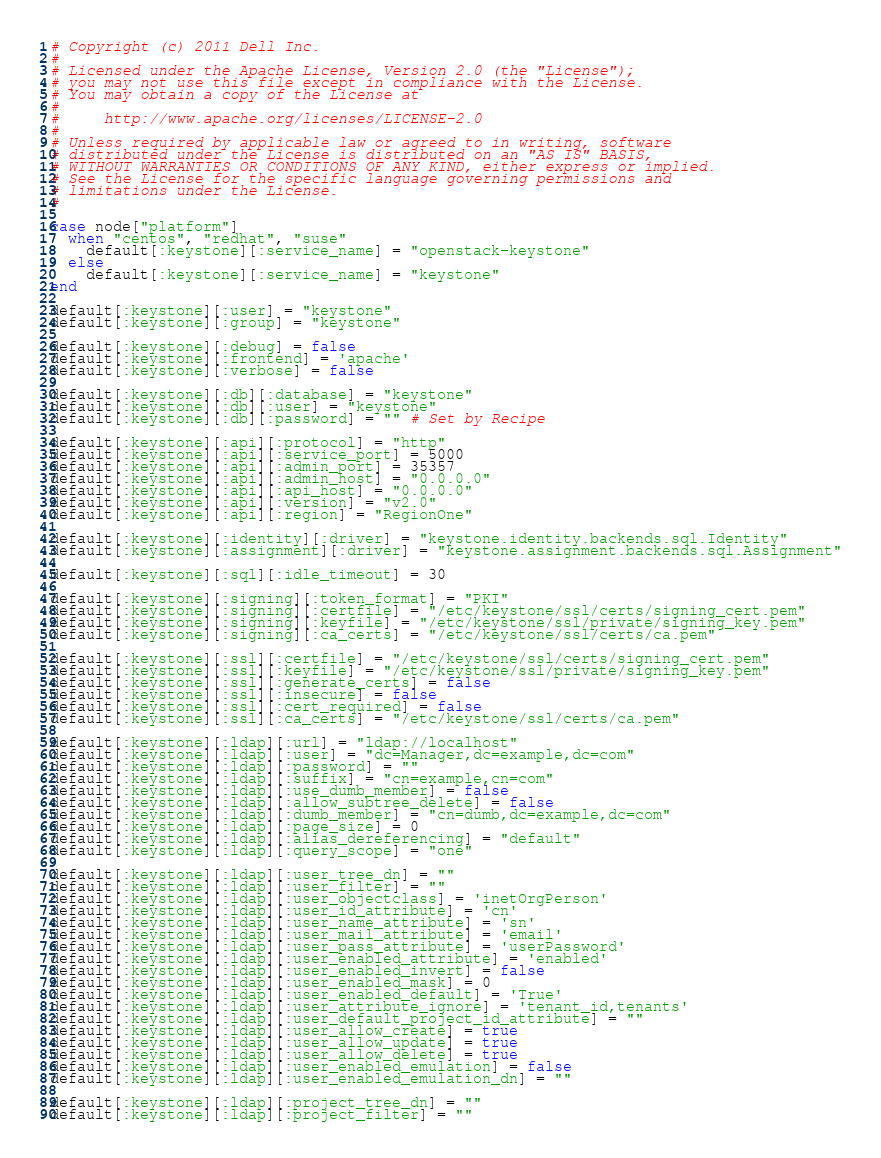Convert code to text. <code><loc_0><loc_0><loc_500><loc_500><_Ruby_>
# Copyright (c) 2011 Dell Inc.
#
# Licensed under the Apache License, Version 2.0 (the "License");
# you may not use this file except in compliance with the License.
# You may obtain a copy of the License at
#
#     http://www.apache.org/licenses/LICENSE-2.0
#
# Unless required by applicable law or agreed to in writing, software
# distributed under the License is distributed on an "AS IS" BASIS,
# WITHOUT WARRANTIES OR CONDITIONS OF ANY KIND, either express or implied.
# See the License for the specific language governing permissions and
# limitations under the License.
#

case node["platform"]
  when "centos", "redhat", "suse"
    default[:keystone][:service_name] = "openstack-keystone"
  else
    default[:keystone][:service_name] = "keystone"
end

default[:keystone][:user] = "keystone"
default[:keystone][:group] = "keystone"

default[:keystone][:debug] = false
default[:keystone][:frontend] = 'apache'
default[:keystone][:verbose] = false

default[:keystone][:db][:database] = "keystone"
default[:keystone][:db][:user] = "keystone"
default[:keystone][:db][:password] = "" # Set by Recipe

default[:keystone][:api][:protocol] = "http"
default[:keystone][:api][:service_port] = 5000
default[:keystone][:api][:admin_port] = 35357
default[:keystone][:api][:admin_host] = "0.0.0.0"
default[:keystone][:api][:api_host] = "0.0.0.0"
default[:keystone][:api][:version] = "v2.0"
default[:keystone][:api][:region] = "RegionOne"

default[:keystone][:identity][:driver] = "keystone.identity.backends.sql.Identity"
default[:keystone][:assignment][:driver] = "keystone.assignment.backends.sql.Assignment"

default[:keystone][:sql][:idle_timeout] = 30

default[:keystone][:signing][:token_format] = "PKI"
default[:keystone][:signing][:certfile] = "/etc/keystone/ssl/certs/signing_cert.pem"
default[:keystone][:signing][:keyfile] = "/etc/keystone/ssl/private/signing_key.pem"
default[:keystone][:signing][:ca_certs] = "/etc/keystone/ssl/certs/ca.pem"

default[:keystone][:ssl][:certfile] = "/etc/keystone/ssl/certs/signing_cert.pem"
default[:keystone][:ssl][:keyfile] = "/etc/keystone/ssl/private/signing_key.pem"
default[:keystone][:ssl][:generate_certs] = false
default[:keystone][:ssl][:insecure] = false
default[:keystone][:ssl][:cert_required] = false
default[:keystone][:ssl][:ca_certs] = "/etc/keystone/ssl/certs/ca.pem"

default[:keystone][:ldap][:url] = "ldap://localhost"
default[:keystone][:ldap][:user] = "dc=Manager,dc=example,dc=com"
default[:keystone][:ldap][:password] = ""
default[:keystone][:ldap][:suffix] = "cn=example,cn=com"
default[:keystone][:ldap][:use_dumb_member] = false
default[:keystone][:ldap][:allow_subtree_delete] = false
default[:keystone][:ldap][:dumb_member] = "cn=dumb,dc=example,dc=com"
default[:keystone][:ldap][:page_size] = 0
default[:keystone][:ldap][:alias_dereferencing] = "default"
default[:keystone][:ldap][:query_scope] = "one"

default[:keystone][:ldap][:user_tree_dn] = ""
default[:keystone][:ldap][:user_filter] = ""
default[:keystone][:ldap][:user_objectclass] = 'inetOrgPerson'
default[:keystone][:ldap][:user_id_attribute] = 'cn'
default[:keystone][:ldap][:user_name_attribute] = 'sn'
default[:keystone][:ldap][:user_mail_attribute] = 'email'
default[:keystone][:ldap][:user_pass_attribute] = 'userPassword'
default[:keystone][:ldap][:user_enabled_attribute] = 'enabled'
default[:keystone][:ldap][:user_enabled_invert] = false
default[:keystone][:ldap][:user_enabled_mask] = 0
default[:keystone][:ldap][:user_enabled_default] = 'True'
default[:keystone][:ldap][:user_attribute_ignore] = 'tenant_id,tenants'
default[:keystone][:ldap][:user_default_project_id_attribute] = ""
default[:keystone][:ldap][:user_allow_create] = true
default[:keystone][:ldap][:user_allow_update] = true
default[:keystone][:ldap][:user_allow_delete] = true
default[:keystone][:ldap][:user_enabled_emulation] = false
default[:keystone][:ldap][:user_enabled_emulation_dn] = ""

default[:keystone][:ldap][:project_tree_dn] = ""
default[:keystone][:ldap][:project_filter] = ""</code> 